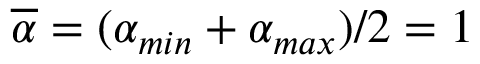Convert formula to latex. <formula><loc_0><loc_0><loc_500><loc_500>\overline { \alpha } = ( \alpha _ { \min } + \alpha _ { \max } ) / 2 = 1</formula> 